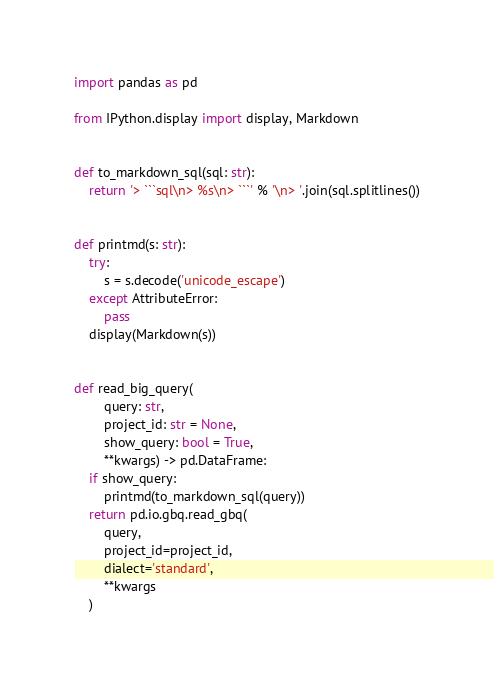<code> <loc_0><loc_0><loc_500><loc_500><_Python_>import pandas as pd

from IPython.display import display, Markdown


def to_markdown_sql(sql: str):
    return '> ```sql\n> %s\n> ```' % '\n> '.join(sql.splitlines())


def printmd(s: str):
    try:
        s = s.decode('unicode_escape')
    except AttributeError:
        pass
    display(Markdown(s))


def read_big_query(
        query: str,
        project_id: str = None,
        show_query: bool = True,
        **kwargs) -> pd.DataFrame:
    if show_query:
        printmd(to_markdown_sql(query))
    return pd.io.gbq.read_gbq(
        query,
        project_id=project_id,
        dialect='standard',
        **kwargs
    )
</code> 